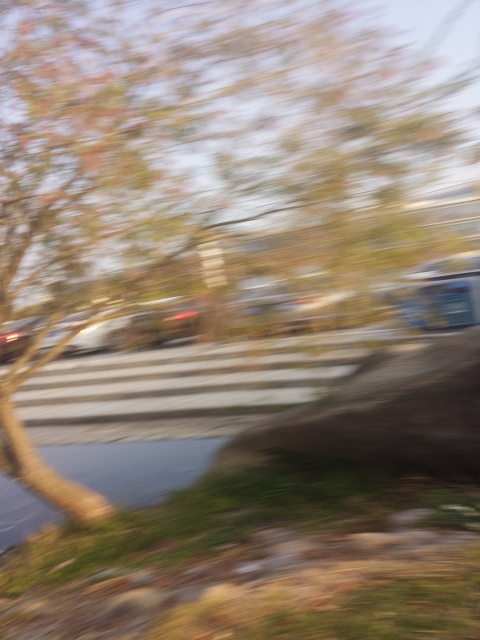How might the motion blur effect in this image inform us about the camera's or the subject's movement? The motion blur effect indicates that either the camera was moving quickly during the shot, or the subject was moving, or perhaps both. The direction of the blur suggests the path of movement; for example, if the blur is horizontal, the movement was likely side-to-side. This can give us clues about the dynamics at play when the image was captured. 